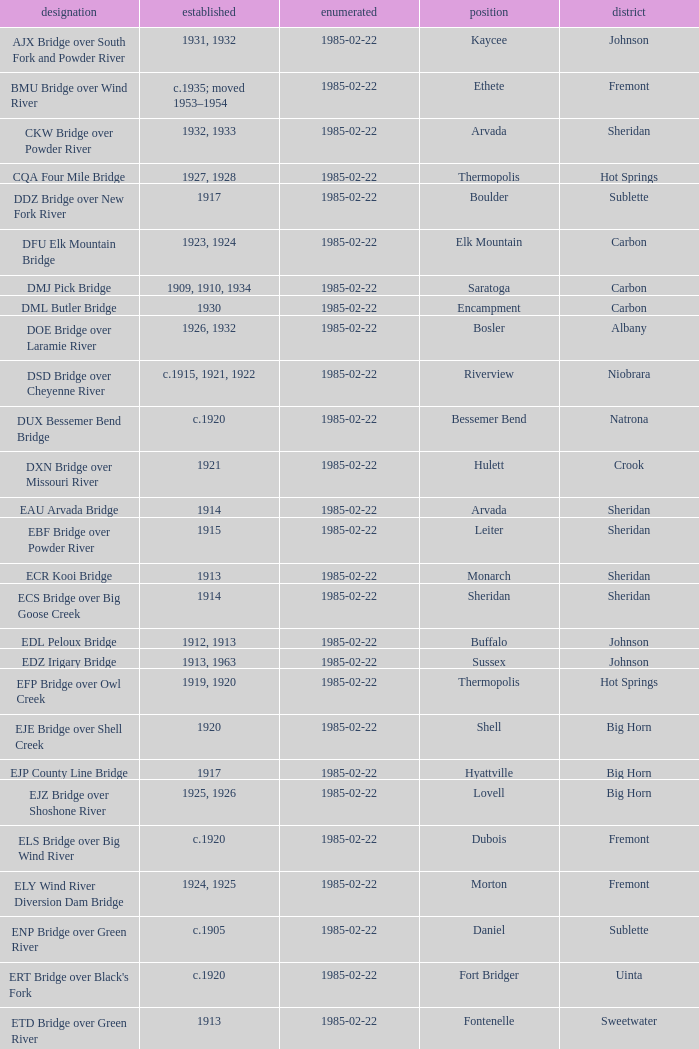What was the year of completion for the bridge in lovell? 1925, 1926. 